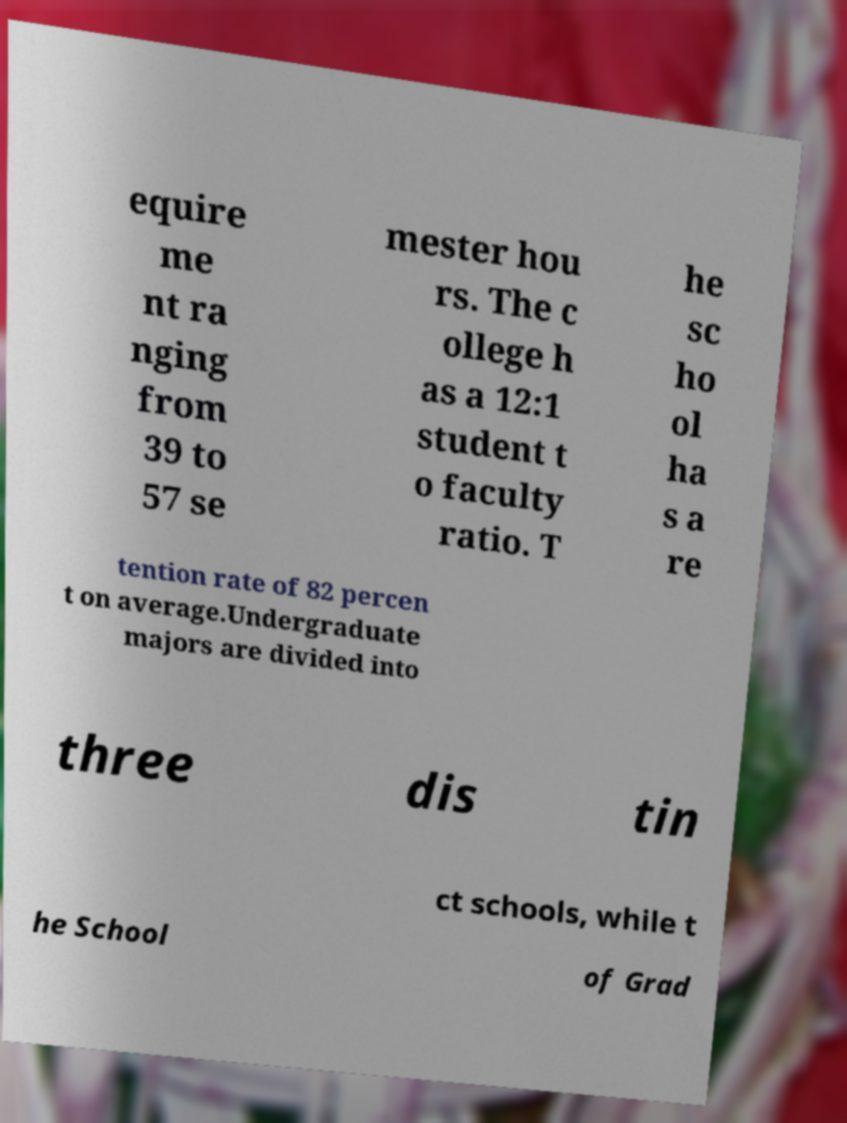Could you extract and type out the text from this image? equire me nt ra nging from 39 to 57 se mester hou rs. The c ollege h as a 12:1 student t o faculty ratio. T he sc ho ol ha s a re tention rate of 82 percen t on average.Undergraduate majors are divided into three dis tin ct schools, while t he School of Grad 